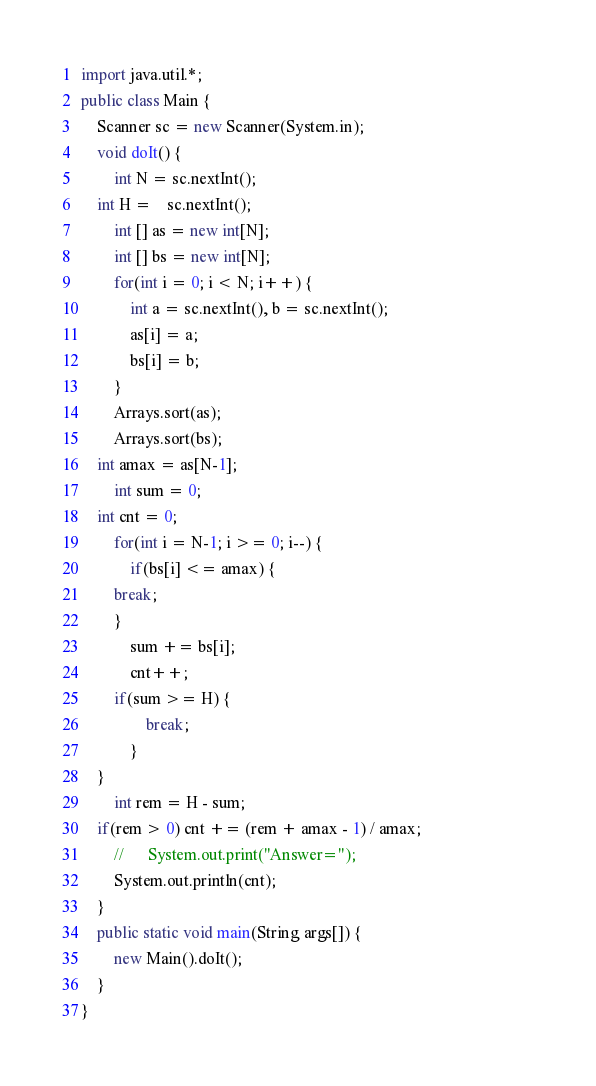<code> <loc_0><loc_0><loc_500><loc_500><_Java_>import java.util.*;
public class Main {
    Scanner sc = new Scanner(System.in);
    void doIt() {
        int N = sc.nextInt();
	int H =	sc.nextInt();
        int [] as = new int[N];
        int [] bs = new int[N];
        for(int i = 0; i < N; i++) {
            int a = sc.nextInt(), b = sc.nextInt();
            as[i] = a;
            bs[i] = b;
        }
        Arrays.sort(as);
        Arrays.sort(bs);
	int amax = as[N-1];
        int sum = 0;
	int cnt = 0;
        for(int i = N-1; i >= 0; i--) {
            if(bs[i] <= amax) {
		break;
	    }
            sum += bs[i];
            cnt++;
	    if(sum >= H) {
                break;
            }
	}
        int rem = H - sum;
	if(rem > 0) cnt += (rem + amax - 1) / amax;
        //      System.out.print("Answer=");                                            
        System.out.println(cnt);
    }
    public static void main(String args[]) {
        new Main().doIt();
    }
}
</code> 